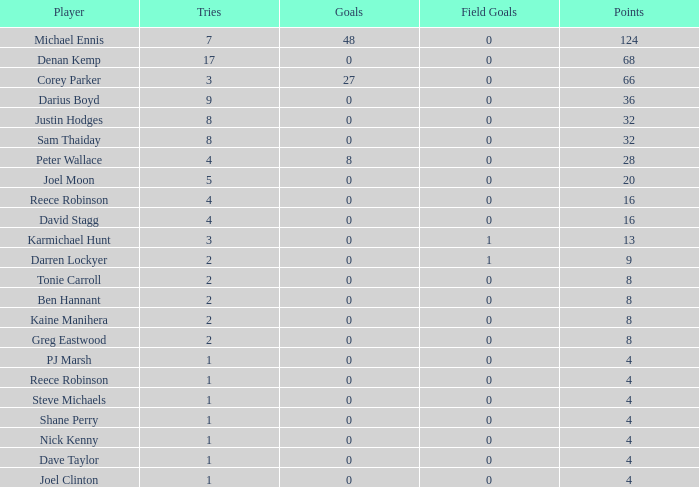With more than 0 goals, 28 points, and over 0 field goals, what is the lowest number of attempts for a player? None. 